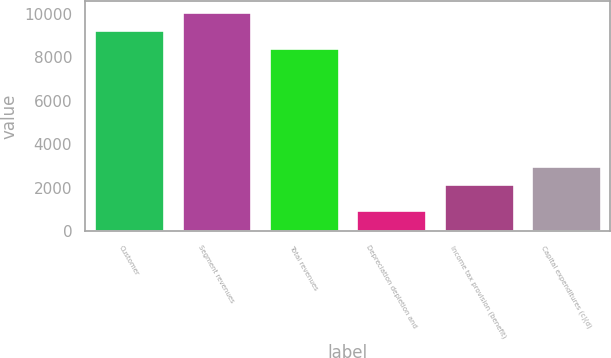Convert chart to OTSL. <chart><loc_0><loc_0><loc_500><loc_500><bar_chart><fcel>Customer<fcel>Segment revenues<fcel>Total revenues<fcel>Depreciation depletion and<fcel>Income tax provision (benefit)<fcel>Capital expenditures (c)(d)<nl><fcel>9245.2<fcel>10064.4<fcel>8426<fcel>963<fcel>2172<fcel>2991.2<nl></chart> 